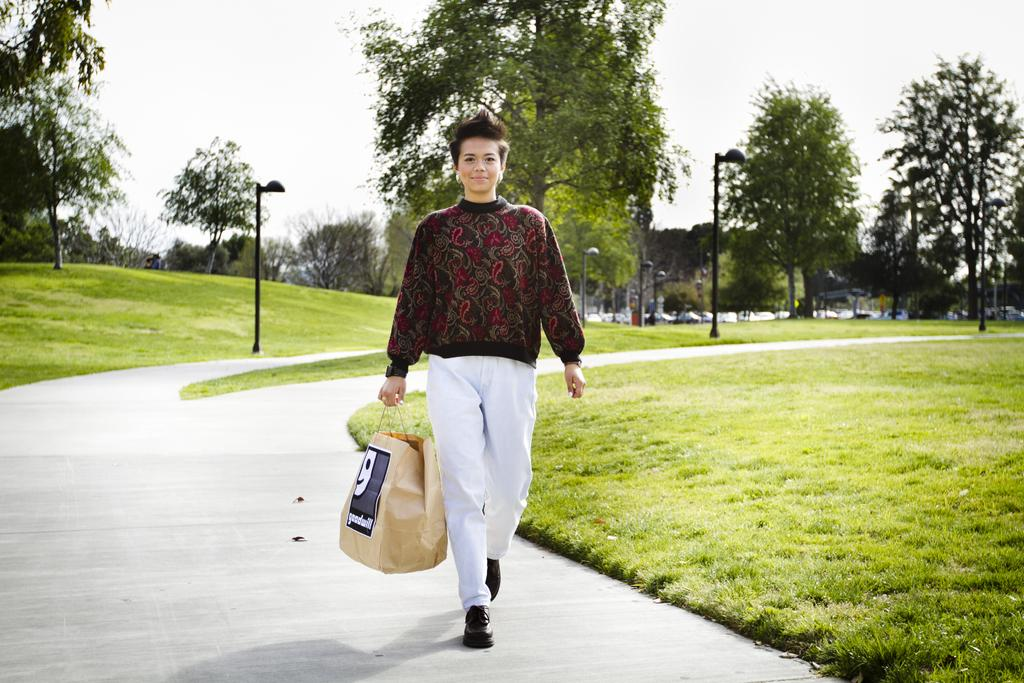Who is the main subject in the image? There is a woman in the image. What is the woman doing in the image? The woman is walking. What is the woman holding in the image? The woman is holding a bag. What can be seen in the background of the image? There is grass, trees, light poles, and the sky visible in the background of the image. What is the woman's income in the image? There is no information about the woman's income in the image. Is there a hill visible in the image? There is no hill visible in the image; only grass, trees, light poles, and the sky are present in the background. 